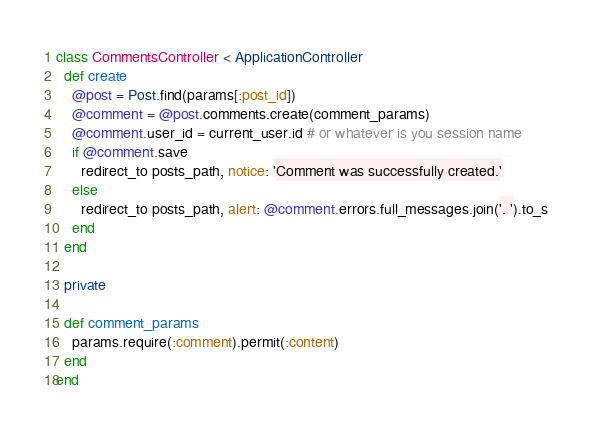<code> <loc_0><loc_0><loc_500><loc_500><_Ruby_>class CommentsController < ApplicationController
  def create
    @post = Post.find(params[:post_id])
    @comment = @post.comments.create(comment_params)
    @comment.user_id = current_user.id # or whatever is you session name
    if @comment.save
      redirect_to posts_path, notice: 'Comment was successfully created.'
    else
      redirect_to posts_path, alert: @comment.errors.full_messages.join('. ').to_s
    end
  end

  private

  def comment_params
    params.require(:comment).permit(:content)
  end
end
</code> 